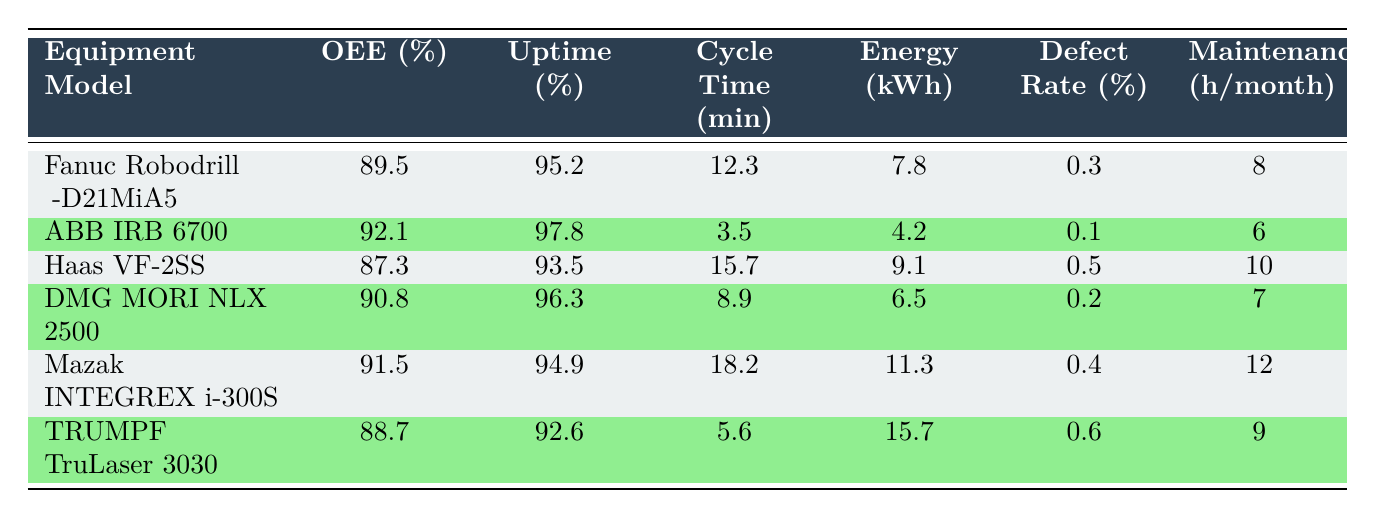What is the OEE percentage of the ABB IRB 6700? The table directly provides the OEE percentage for each equipment model. By locating the row for ABB IRB 6700, I see that the OEE is listed as 92.1%.
Answer: 92.1 Which equipment has the highest uptime percentage? Comparing the uptime percentages listed in the table for each model, ABB IRB 6700 has the highest uptime of 97.8%.
Answer: ABB IRB 6700 What is the average cycle time of all equipment models? To calculate the average cycle time, I first sum all cycle times: (12.3 + 3.5 + 15.7 + 8.9 + 18.2 + 5.6) = 64.2 minutes. There are 6 models, so the average cycle time is 64.2 / 6 ≈ 10.7 minutes.
Answer: 10.7 Is the defect rate of the Fanuc Robodrill α-D21MiA5 higher than that of the DMG MORI NLX 2500? The Fanuc Robodrill has a defect rate of 0.3%, while the DMG MORI NLX 2500 has a defect rate of 0.2%. Since 0.3% is greater than 0.2%, the statement is true.
Answer: Yes What is the difference in energy consumption between the TRUMPF TruLaser 3030 and ABB IRB 6700? First, I note the energy consumption for both models: TRUMPF TruLaser 3030 uses 15.7 kWh and ABB IRB 6700 uses 4.2 kWh. The difference is calculated as 15.7 - 4.2 = 11.5 kWh.
Answer: 11.5 Which equipment model has the lowest defect rate? I examine the defect rates across the table: Fanuc Robodrill (0.3%), ABB IRB 6700 (0.1%), Haas VF-2SS (0.5%), DMG MORI NLX 2500 (0.2%), Mazak INTEGREX i-300S (0.4%), and TRUMPF TruLaser 3030 (0.6%). The lowest defect rate is thus for ABB IRB 6700 at 0.1%.
Answer: ABB IRB 6700 How many maintenance hours are required per month for Mazak INTEGREX i-300S? The table directly states the maintenance hours for each equipment model, and for Mazak INTEGREX i-300S, the maintenance requirement is 12 hours per month.
Answer: 12 Does the average OEE of the equipment models exceed 90%? I find the OEE values: 89.5, 92.1, 87.3, 90.8, 91.5, and 88.7. Their sum is 89.5 + 92.1 + 87.3 + 90.8 + 91.5 + 88.7 = 539.9. Dividing by 6 gives an average of about 89.983%, which does not exceed 90%.
Answer: No 